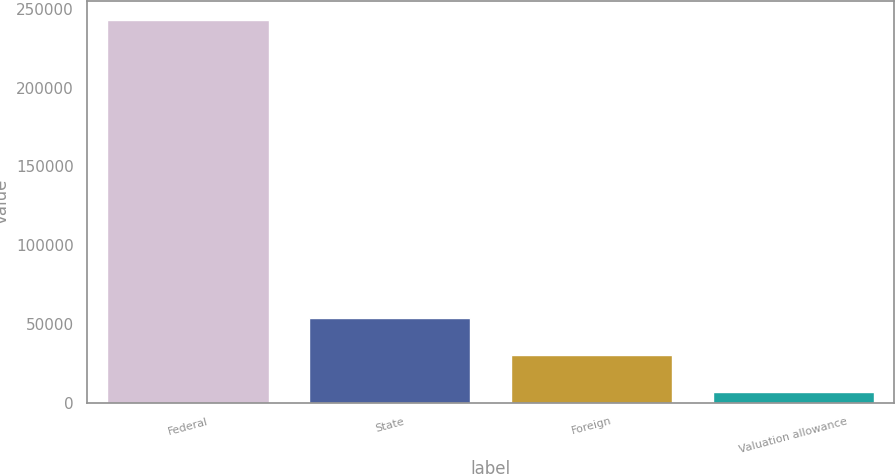Convert chart. <chart><loc_0><loc_0><loc_500><loc_500><bar_chart><fcel>Federal<fcel>State<fcel>Foreign<fcel>Valuation allowance<nl><fcel>243127<fcel>54036.6<fcel>30400.3<fcel>6764<nl></chart> 